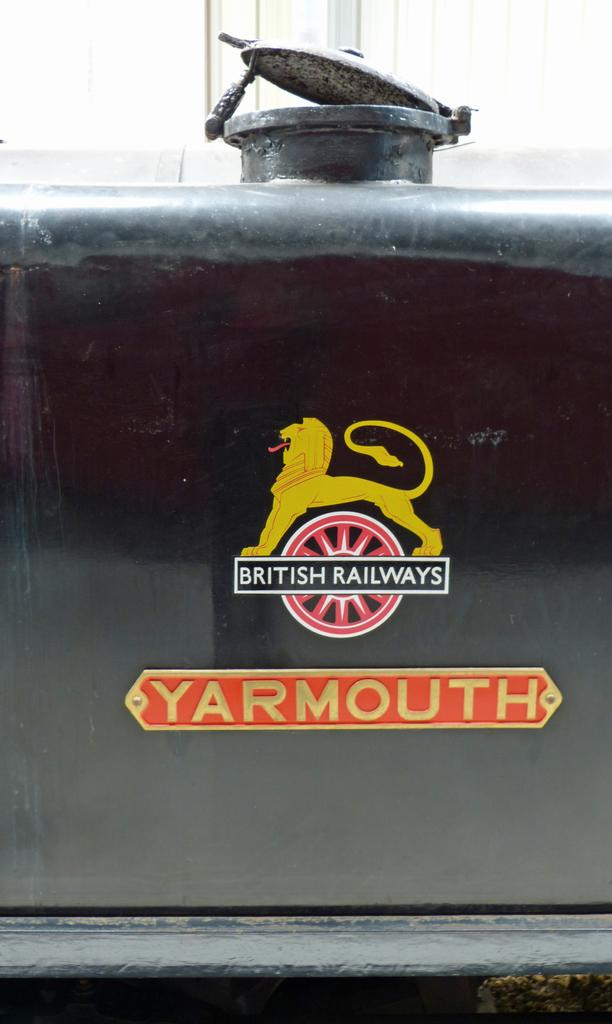What is the main object in the image? There is a name board in the image. What is featured on the tank in the image? There is a logo on a tank in the image. What is the tank's condition? The tank has a lid. What can be seen in the background of the image? There are windows visible in the background of the image. Is the tank filled with hot water in the image? There is no indication in the image about the temperature of the water in the tank. Can you see any bees flying around the name board in the image? There are no bees present in the image. 